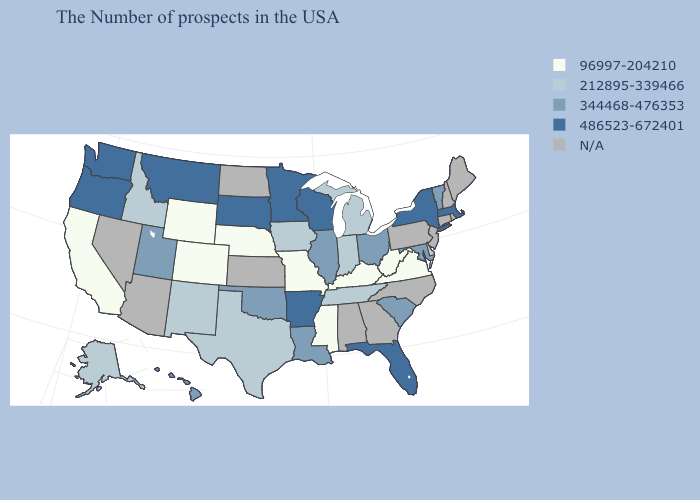Name the states that have a value in the range 486523-672401?
Write a very short answer. Massachusetts, New York, Florida, Wisconsin, Arkansas, Minnesota, South Dakota, Montana, Washington, Oregon. Name the states that have a value in the range N/A?
Write a very short answer. Maine, Rhode Island, New Hampshire, Connecticut, New Jersey, Pennsylvania, North Carolina, Georgia, Alabama, Kansas, North Dakota, Arizona, Nevada. Among the states that border Massachusetts , which have the lowest value?
Give a very brief answer. Vermont. Is the legend a continuous bar?
Be succinct. No. What is the lowest value in the West?
Quick response, please. 96997-204210. Does Wyoming have the lowest value in the USA?
Concise answer only. Yes. Which states have the lowest value in the USA?
Be succinct. Virginia, West Virginia, Kentucky, Mississippi, Missouri, Nebraska, Wyoming, Colorado, California. What is the highest value in the USA?
Give a very brief answer. 486523-672401. Name the states that have a value in the range 486523-672401?
Be succinct. Massachusetts, New York, Florida, Wisconsin, Arkansas, Minnesota, South Dakota, Montana, Washington, Oregon. Name the states that have a value in the range 96997-204210?
Answer briefly. Virginia, West Virginia, Kentucky, Mississippi, Missouri, Nebraska, Wyoming, Colorado, California. What is the value of Wyoming?
Be succinct. 96997-204210. What is the value of Arkansas?
Write a very short answer. 486523-672401. What is the value of Georgia?
Be succinct. N/A. Name the states that have a value in the range 486523-672401?
Quick response, please. Massachusetts, New York, Florida, Wisconsin, Arkansas, Minnesota, South Dakota, Montana, Washington, Oregon. 